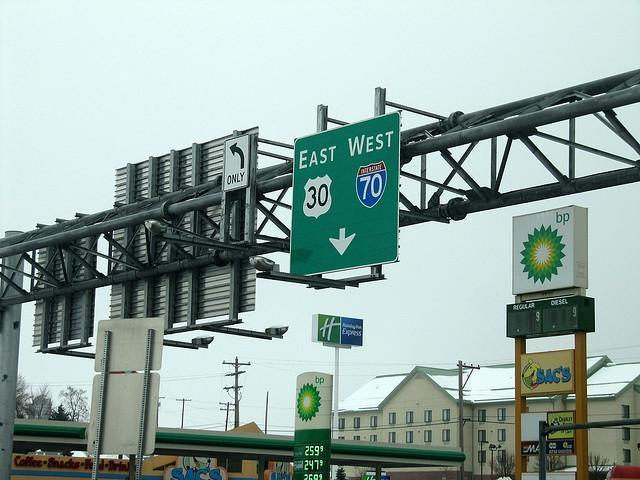How many highway signs are on the pole?
Give a very brief answer. 3. 